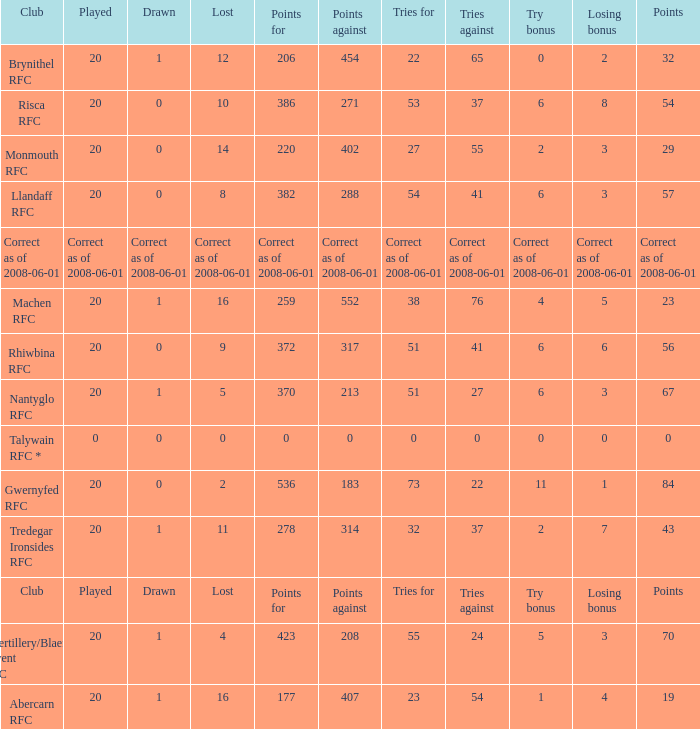Name the tries when tries against were 41, try bonus was 6, and had 317 points. 51.0. 